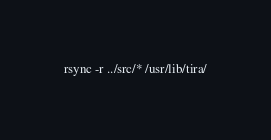Convert code to text. <code><loc_0><loc_0><loc_500><loc_500><_Bash_>rsync -r ../src/* /usr/lib/tira/
</code> 